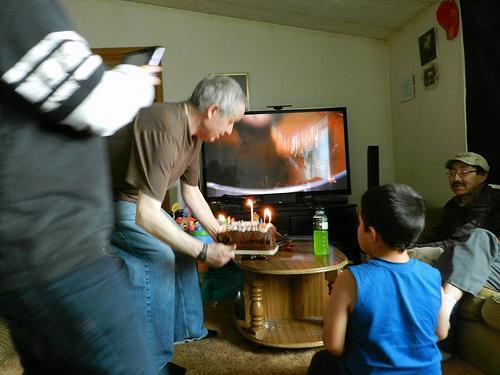How many people are eating cake?
Give a very brief answer. 0. How many people are wearing glasses in this image?
Give a very brief answer. 1. 